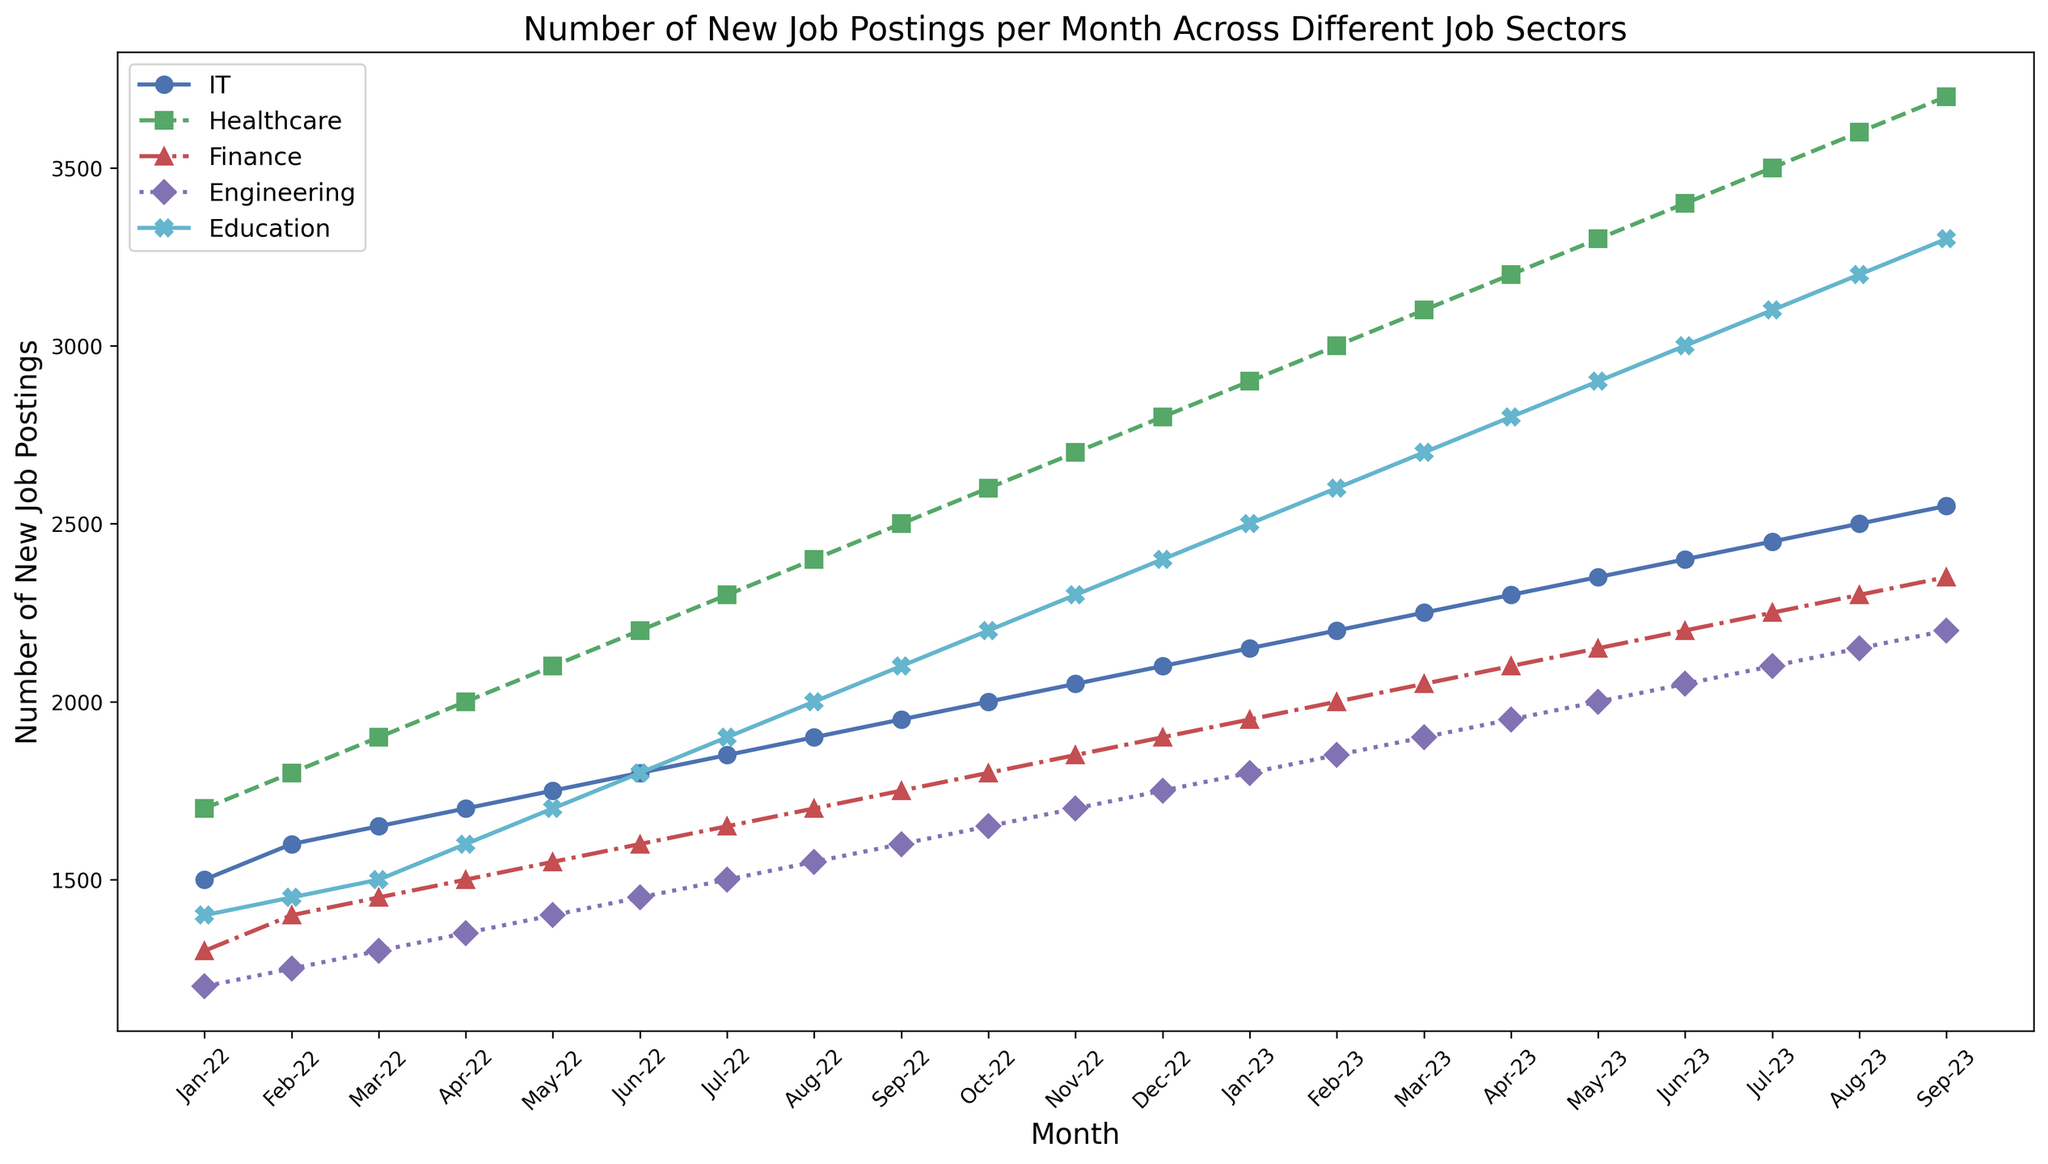What job sector had the highest number of job postings in September 2023? To find the job sector with the highest number of job postings in September 2023, locate the September 2023 data point on the x-axis and compare the heights of the lines for each job sector. The highest point corresponds to the Healthcare sector.
Answer: Healthcare Which month saw the lowest number of job postings for the IT sector? Locate the IT sector line (blue) and identify the lowest point along this line. The lowest point occurs in January 2022.
Answer: January 2022 How much did the number of job postings in the Education sector increase between January 2022 and September 2023? Identify the values for the Education sector in January 2022 (1400) and September 2023 (3300). Subtract the January 2022 value from the September 2023 value: 3300 - 1400 = 1900.
Answer: 1900 Which sectors had more job postings in March 2023 compared to March 2022? Locate the data points for each sector in March 2022 and March 2023. Compare these points: IT (1650 vs 2250), Healthcare (1900 vs 3100), Finance (1450 vs 2050), Engineering (1300 vs 1900), and Education (1500 vs 2700). All sectors had more postings in March 2023.
Answer: All sectors In which month did the Finance sector first surpass 2000 job postings? Locate the Finance sector line (red) and track the points until it surpasses the 2000 posting mark. This occurs in February 2023 with 2000 postings.
Answer: February 2023 What is the average number of new job postings per month for the Engineering sector between January 2022 and September 2023? The number of months is 21. Sum the data points for the Engineering sector over these months: 1200 + 1250 + 1300 + 1350 + 1400 + 1450 + 1500 + 1550 + 1600 + 1650 + 1700 + 1750 + 1800 + 1850 + 1900 + 1950 + 2000 + 2050 + 2100 + 2150 + 2200 = 36,450. Divide this sum by 21: 36,450 / 21 = 1735.71.
Answer: 1735.71 Which sector showed the most consistent increase in job postings over the entire period? Examine the steepness and regularity of the lines for each sector: the Healthcare sector (green) shows a consistent and steep increase throughout the period.
Answer: Healthcare How many job sectors had more than 3000 postings in June 2023? Locate the June 2023 data points for all sectors: IT (2400), Healthcare (3400), Finance (2200), Engineering (2050), and Education (3000). Compare these values to 3000. Three sectors - Healthcare, Engineering, and Education - surpass 3000 postings.
Answer: Three sectors What is the difference in job postings between IT and Education sectors in November 2022? Identify the November 2022 values for IT (2050) and Education (2300). Subtract the IT value from the Education value: 2300 - 2050 = 250.
Answer: 250 